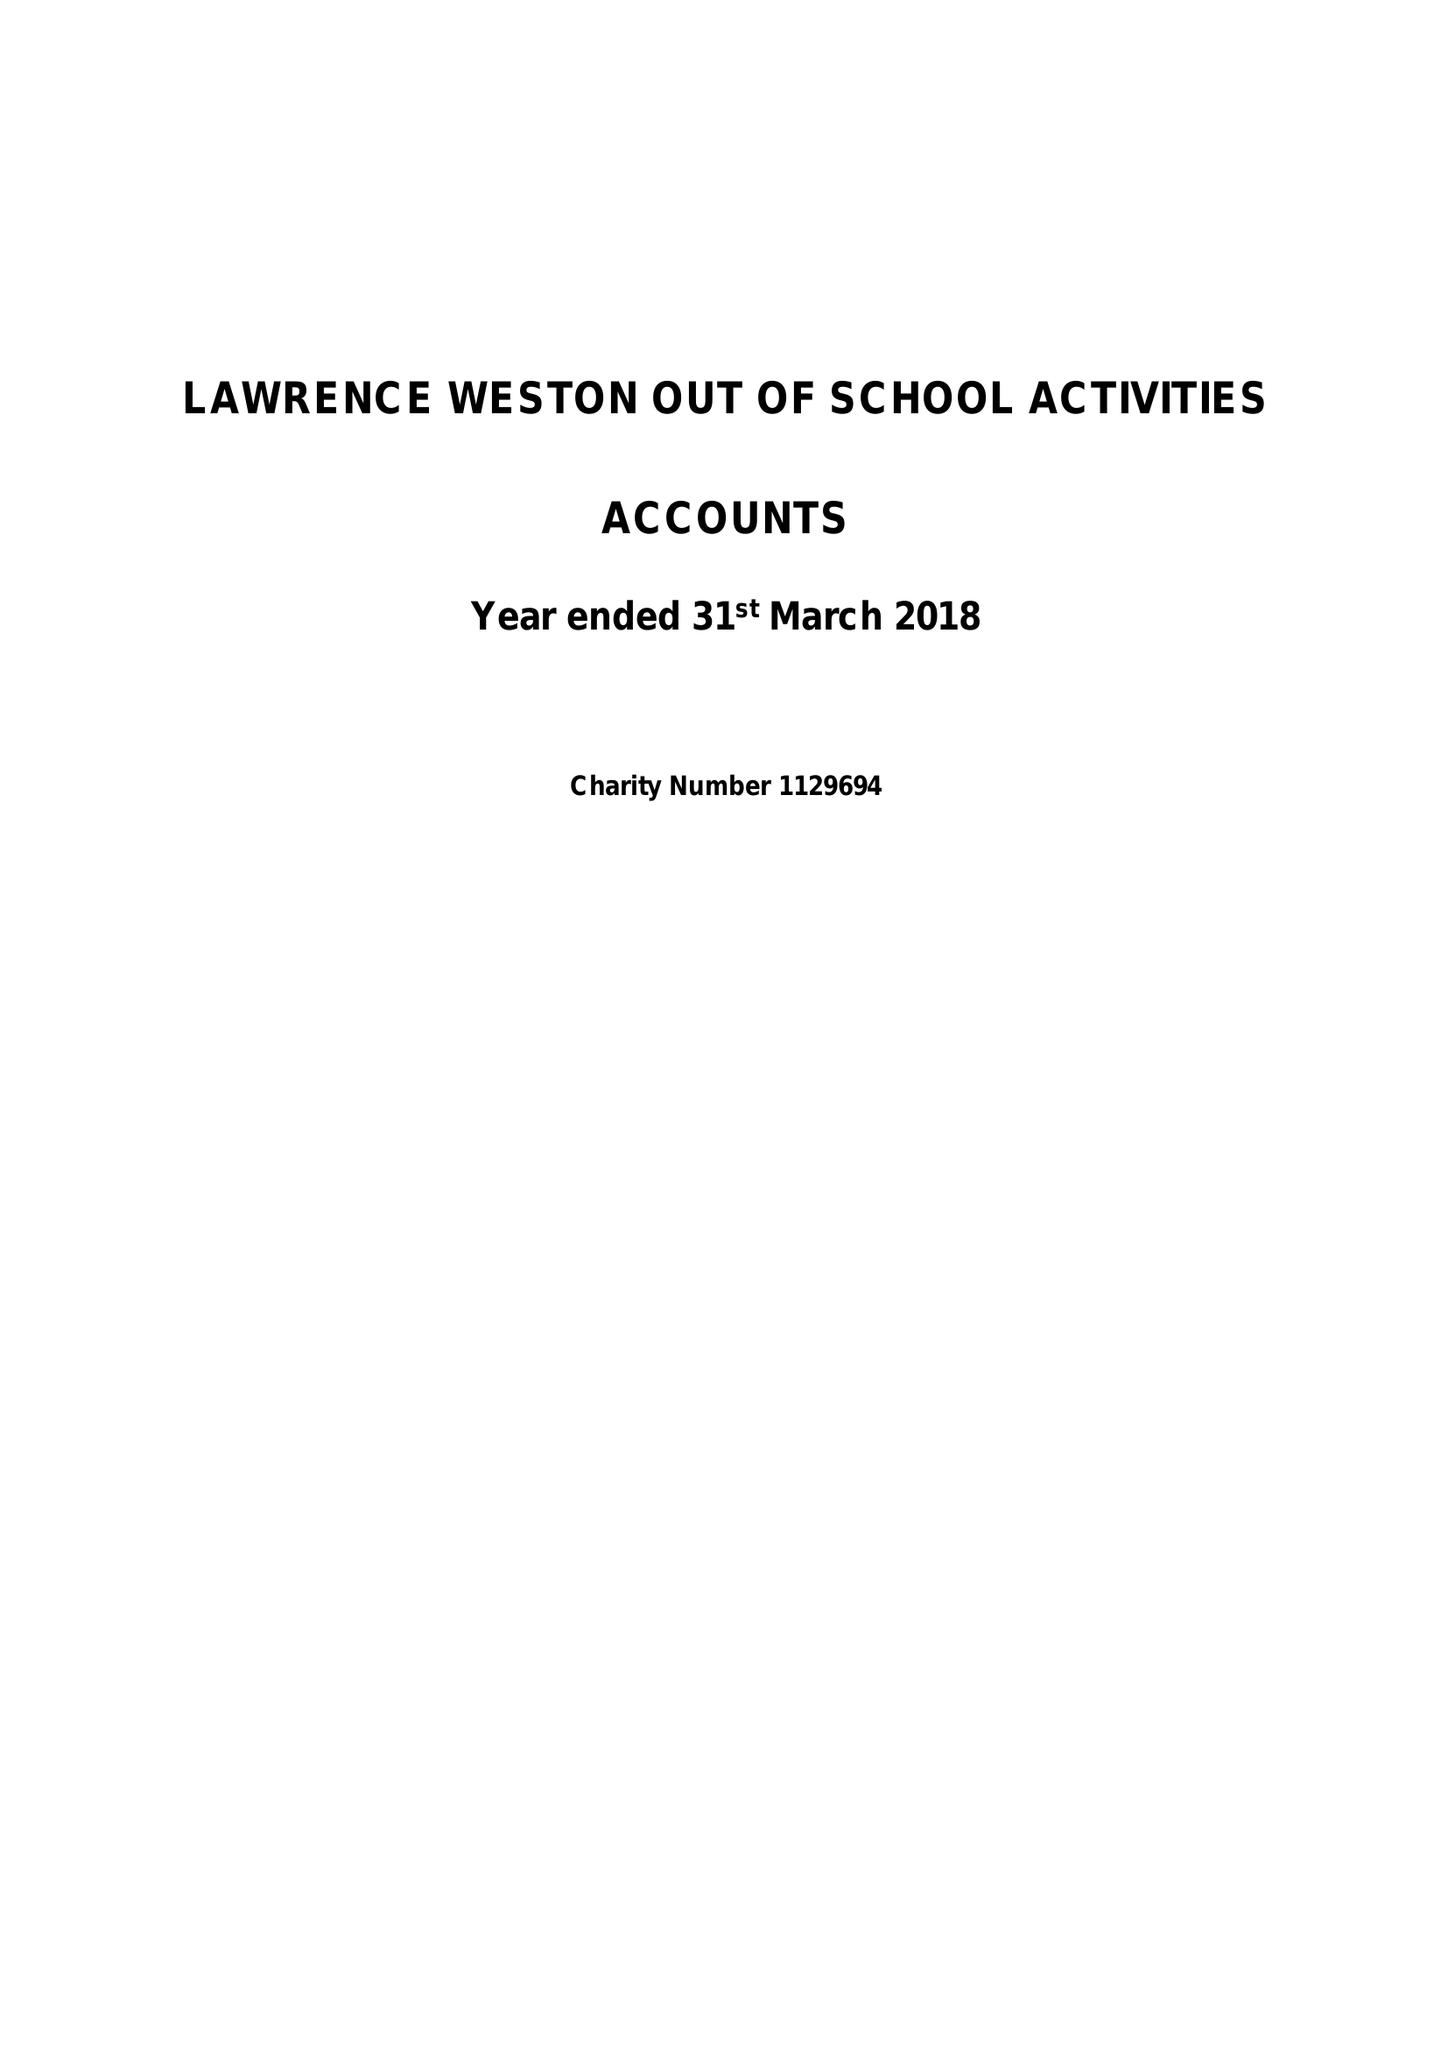What is the value for the address__postcode?
Answer the question using a single word or phrase. BS11 0QF 